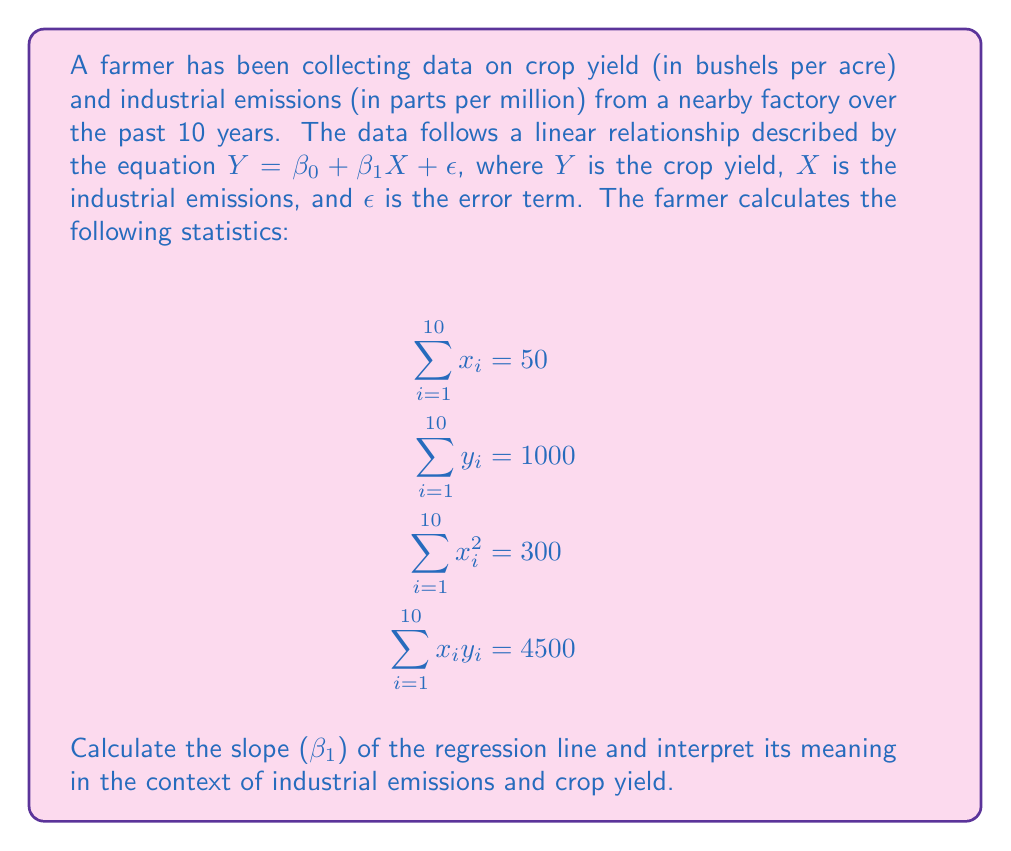What is the answer to this math problem? To calculate the slope ($\beta_1$) of the regression line, we'll use the least squares formula:

$$\beta_1 = \frac{n\sum x_iy_i - \sum x_i \sum y_i}{n\sum x_i^2 - (\sum x_i)^2}$$

Where:
$n = 10$ (number of years)
$\sum x_i = 50$
$\sum y_i = 1000$
$\sum x_i^2 = 300$
$\sum x_iy_i = 4500$

Step 1: Calculate the numerator
$10 \cdot 4500 - 50 \cdot 1000 = 45000 - 50000 = -5000$

Step 2: Calculate the denominator
$10 \cdot 300 - 50^2 = 3000 - 2500 = 500$

Step 3: Divide the numerator by the denominator
$$\beta_1 = \frac{-5000}{500} = -10$$

Interpretation: The slope ($\beta_1$) is -10, which means that for every 1 part per million increase in industrial emissions, the crop yield decreases by 10 bushels per acre, on average. This negative relationship indicates that industrial emissions have a detrimental effect on crop yield.
Answer: $\beta_1 = -10$ bushels per acre / ppm 